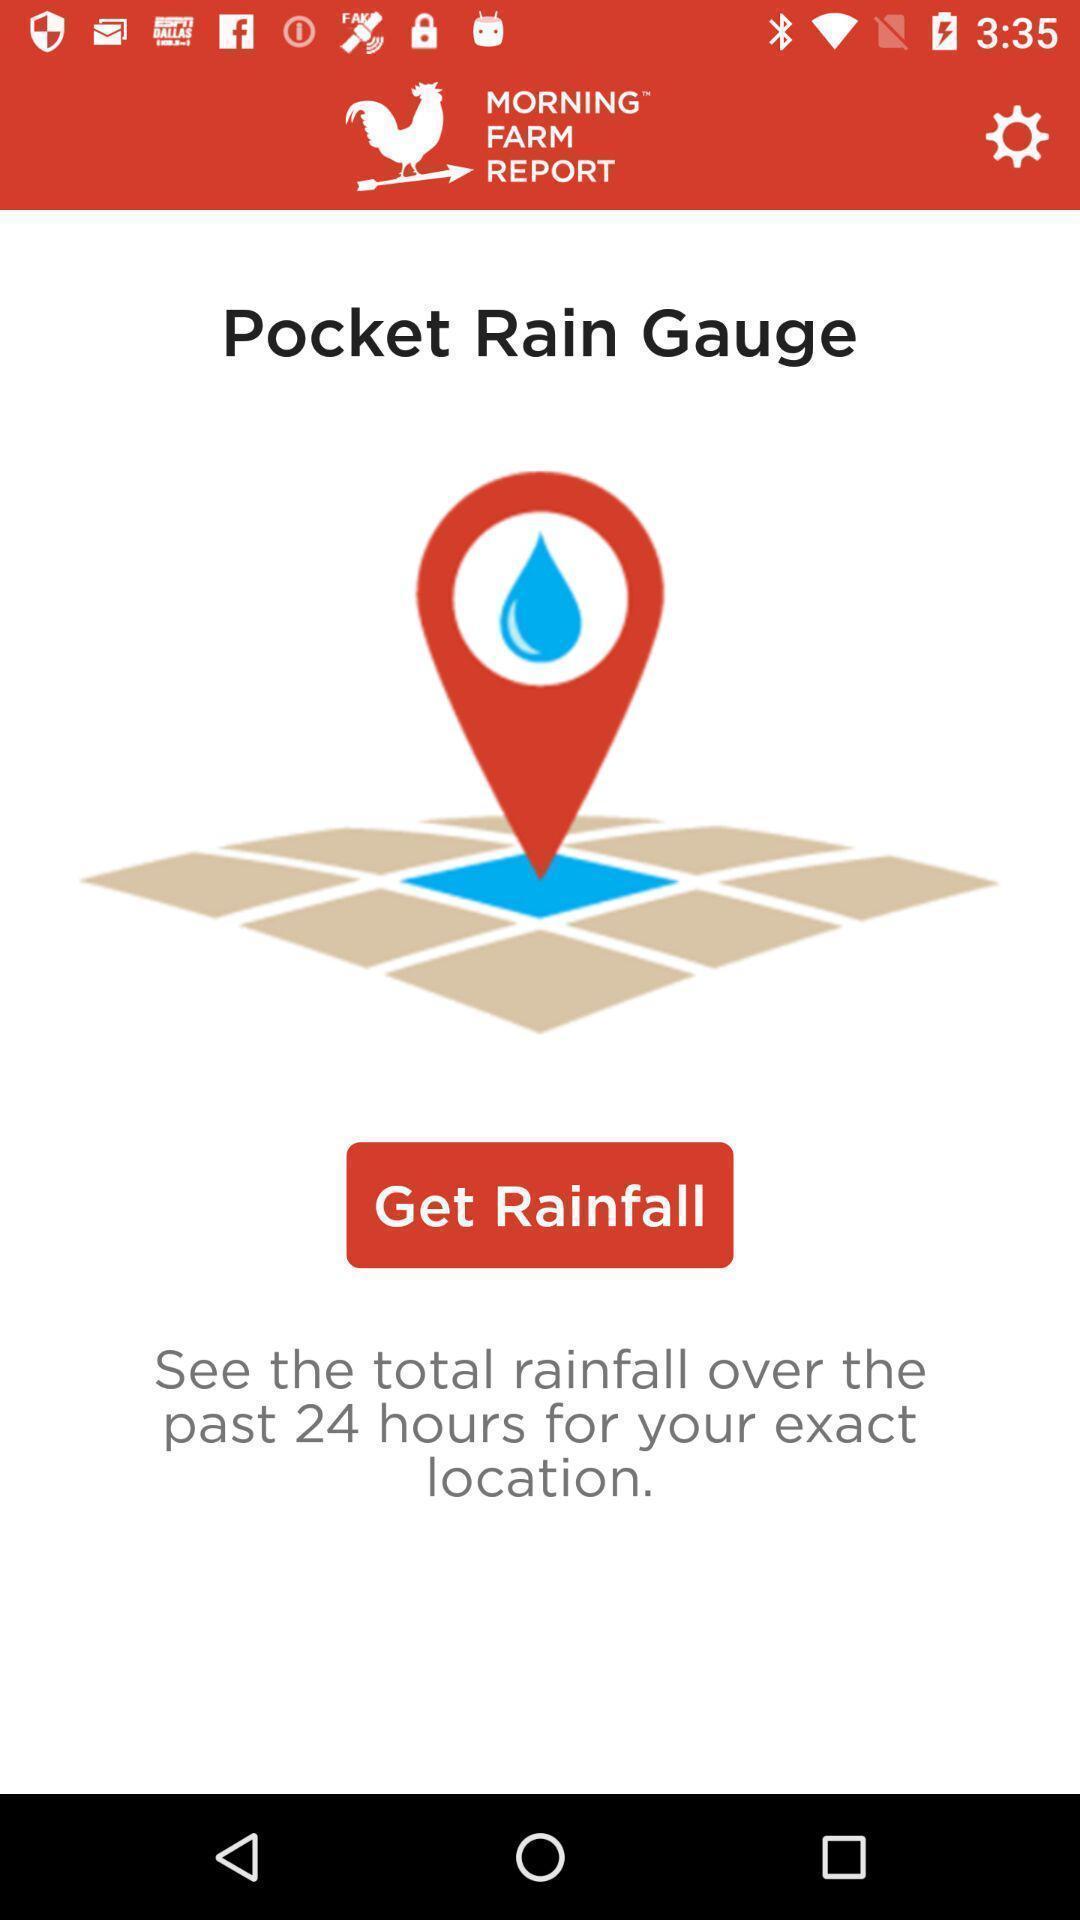What can you discern from this picture? Window displaying an app regarding rainfall. 